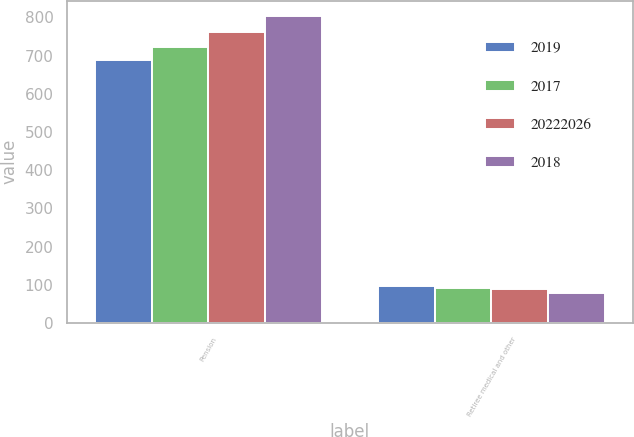Convert chart. <chart><loc_0><loc_0><loc_500><loc_500><stacked_bar_chart><ecel><fcel>Pension<fcel>Retiree medical and other<nl><fcel>2019<fcel>688<fcel>97<nl><fcel>2017<fcel>722<fcel>93<nl><fcel>2.0222e+07<fcel>762<fcel>88<nl><fcel>2018<fcel>804<fcel>79<nl></chart> 